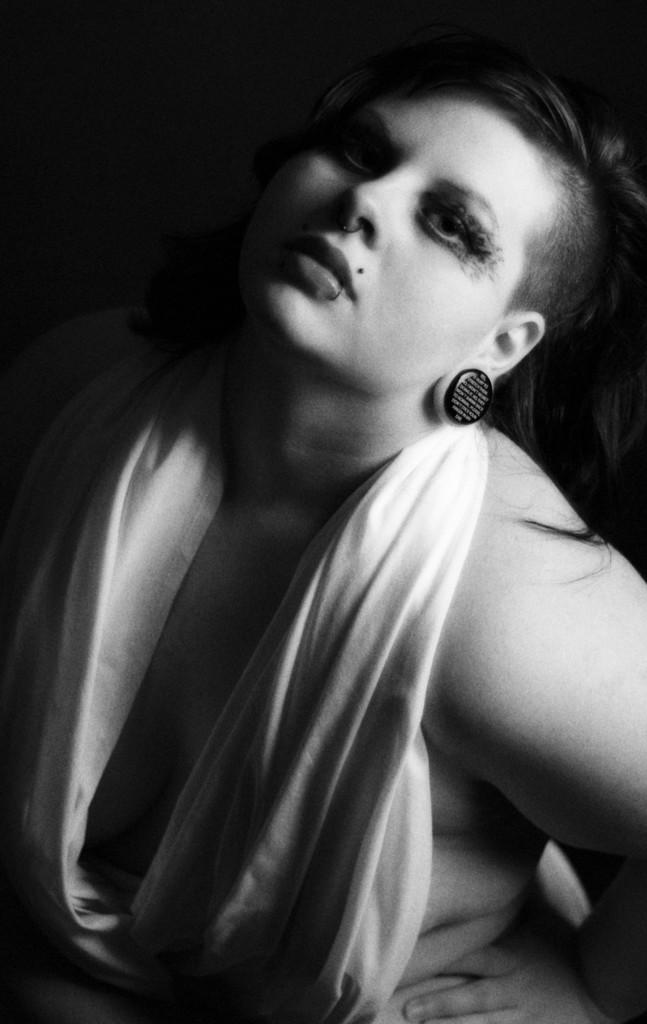What is the color scheme of the image? The image is black and white. Can you describe the main subject in the image? There is a lady in the image. What type of pest can be seen crawling on the lady's shoulder in the image? There is no pest visible on the lady's shoulder in the image. What rhythm is the lady dancing to in the image? The image is black and white, and there is no indication of dancing or rhythm in the image. 